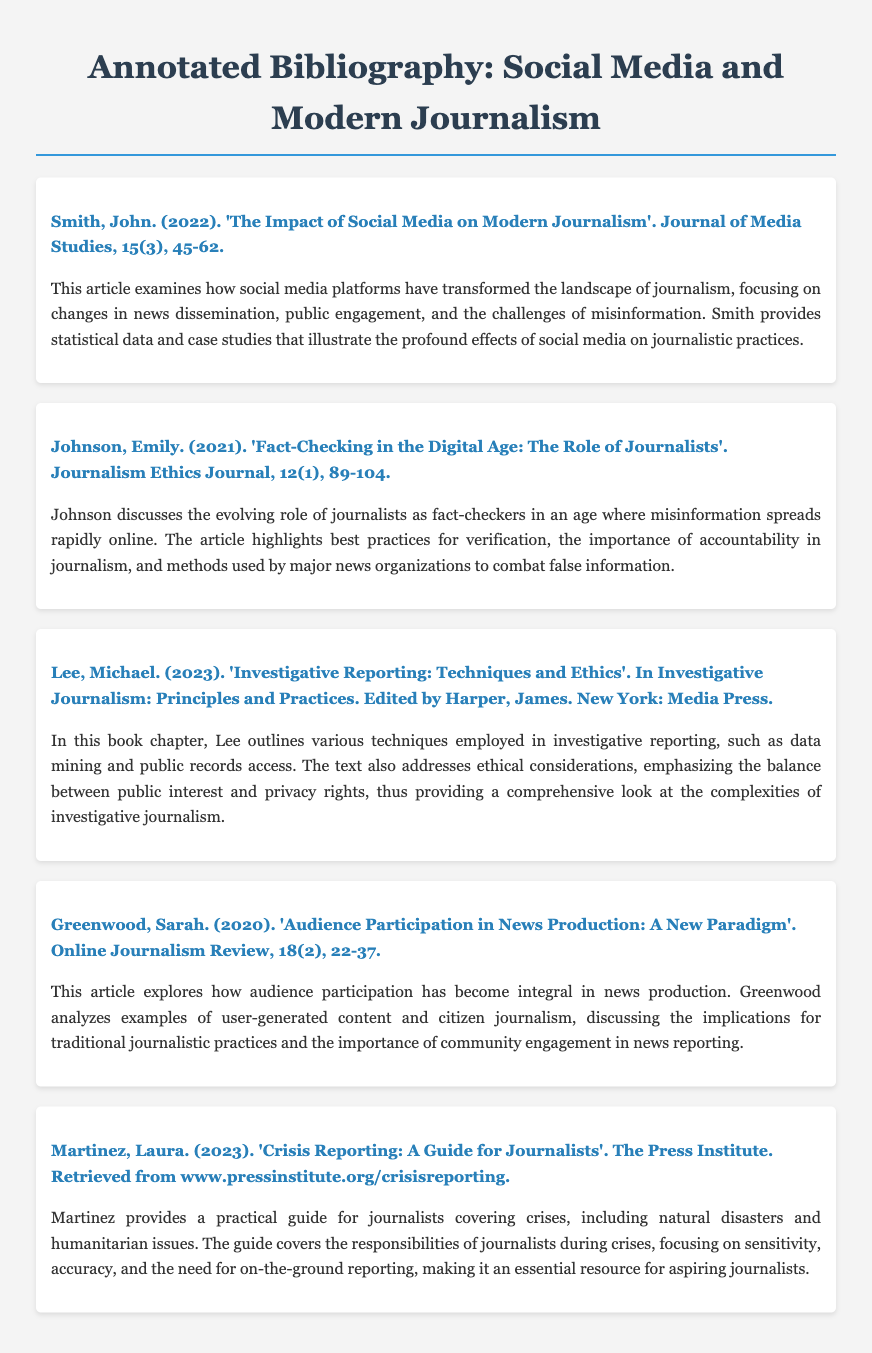What is the title of the bibliography? The title of the bibliography is displayed prominently at the top of the document.
Answer: Annotated Bibliography: Social Media and Modern Journalism How many sources are included in the bibliography? The document lists five distinct sources as entries.
Answer: 5 Who is the author of the article discussing fact-checking? The specific article on fact-checking names its author at the beginning of the entry.
Answer: Johnson, Emily What year was the source about audience participation published? The publication year is indicated in the citation of the specific entry.
Answer: 2020 What is the main focus of Smith's article? The annotation provides a summary of the content and focus of Smith's article.
Answer: Impact of Social Media on Modern Journalism In what publication was the entry about investigative reporting found? The citation specifies the edited volume where the chapter is published.
Answer: Investigative Journalism: Principles and Practices Which author's work discusses crisis reporting? The source is identified in the citation of the relevant entry in the document.
Answer: Martinez, Laura What does the entry by Greenwood analyze? The annotation summarizes the main topic covered in Greenwood's article.
Answer: Audience participation in news production What is the last name of the author who wrote about investigative reporting techniques? The author's last name is part of the citation in that entry.
Answer: Lee 